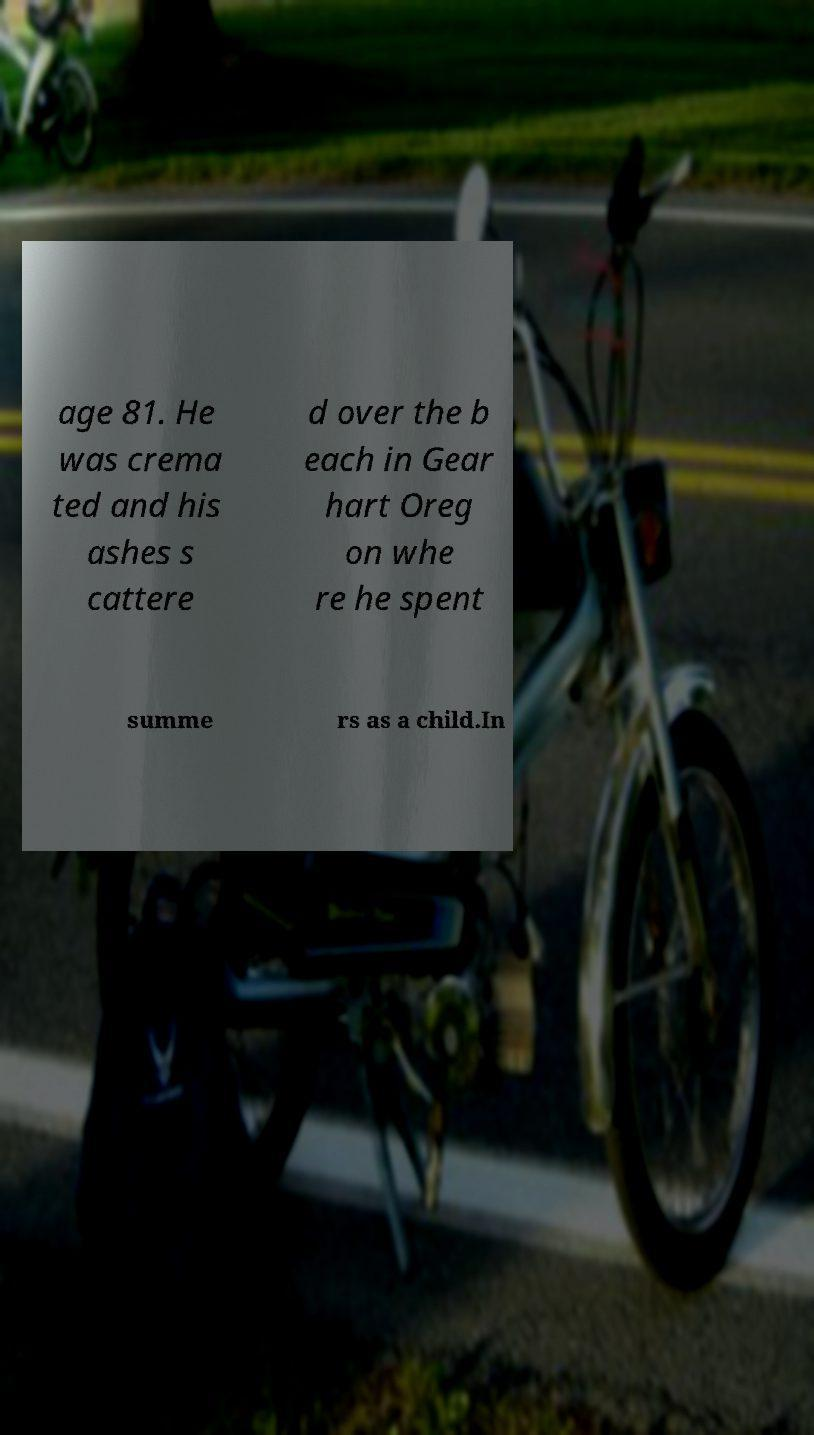Can you read and provide the text displayed in the image?This photo seems to have some interesting text. Can you extract and type it out for me? age 81. He was crema ted and his ashes s cattere d over the b each in Gear hart Oreg on whe re he spent summe rs as a child.In 